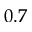<formula> <loc_0><loc_0><loc_500><loc_500>0 . 7</formula> 